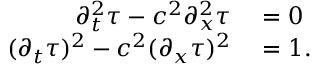<formula> <loc_0><loc_0><loc_500><loc_500>\begin{array} { r l } { \partial _ { t } ^ { 2 } \tau - c ^ { 2 } \partial _ { x } ^ { 2 } \tau } & = 0 } \\ { ( \partial _ { t } \tau ) ^ { 2 } - c ^ { 2 } ( \partial _ { x } \tau ) ^ { 2 } } & = 1 . } \end{array}</formula> 